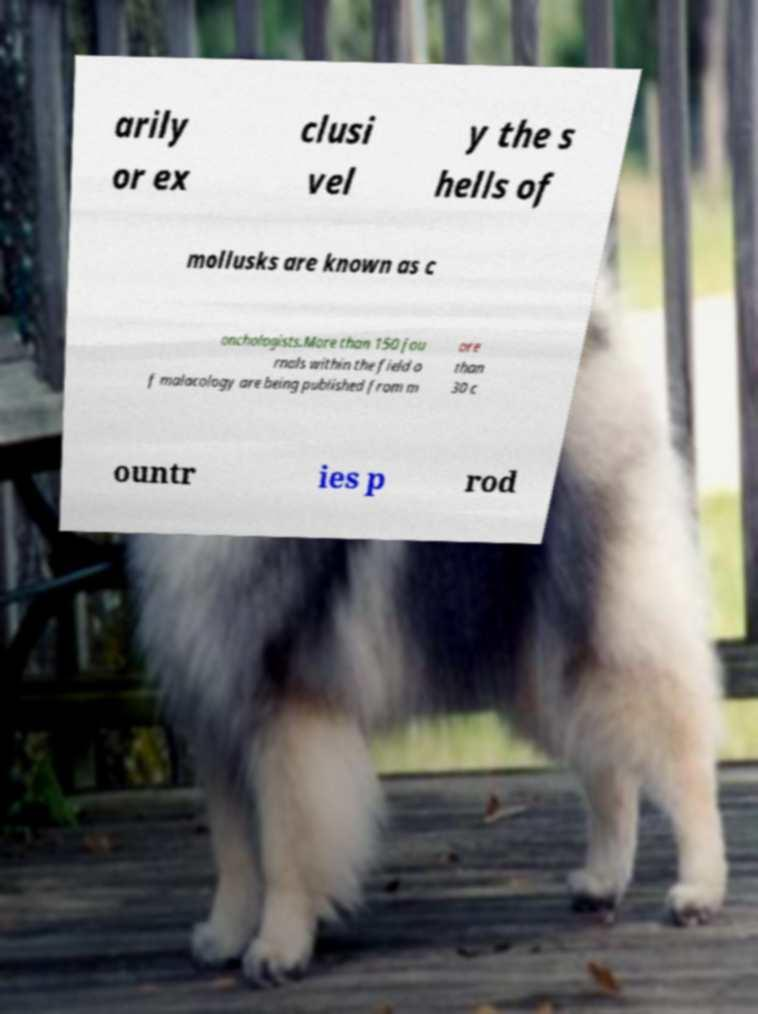For documentation purposes, I need the text within this image transcribed. Could you provide that? arily or ex clusi vel y the s hells of mollusks are known as c onchologists.More than 150 jou rnals within the field o f malacology are being published from m ore than 30 c ountr ies p rod 